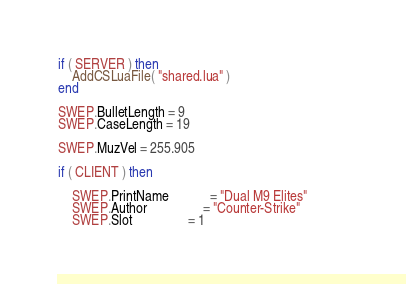Convert code to text. <code><loc_0><loc_0><loc_500><loc_500><_Lua_>if ( SERVER ) then
	AddCSLuaFile( "shared.lua" )
end

SWEP.BulletLength = 9
SWEP.CaseLength = 19

SWEP.MuzVel = 255.905

if ( CLIENT ) then

	SWEP.PrintName			= "Dual M9 Elites"			
	SWEP.Author				= "Counter-Strike"
	SWEP.Slot				= 1</code> 